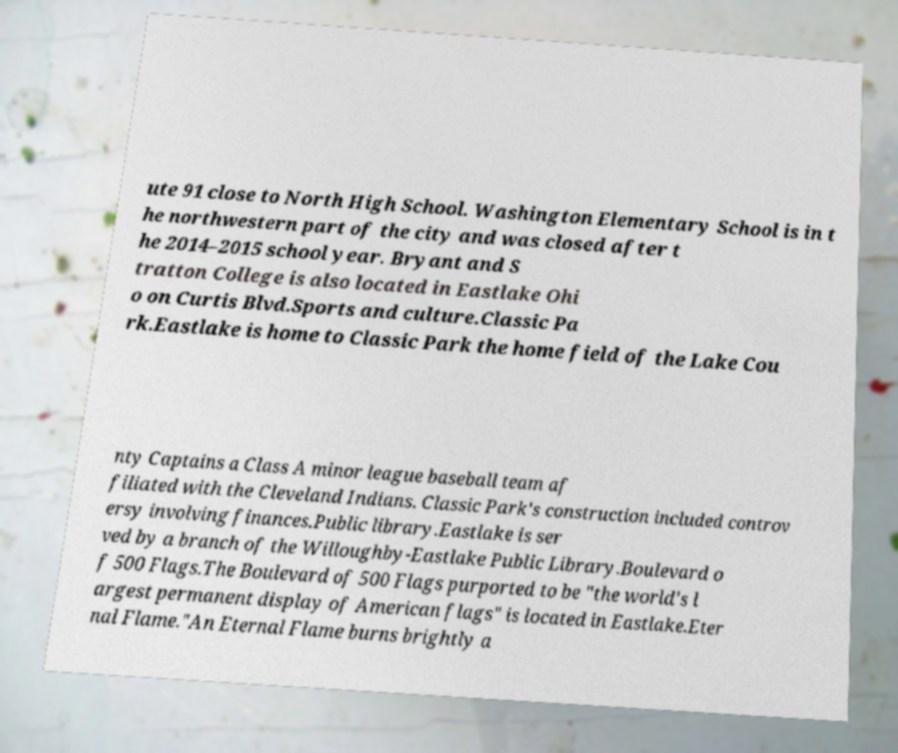I need the written content from this picture converted into text. Can you do that? ute 91 close to North High School. Washington Elementary School is in t he northwestern part of the city and was closed after t he 2014–2015 school year. Bryant and S tratton College is also located in Eastlake Ohi o on Curtis Blvd.Sports and culture.Classic Pa rk.Eastlake is home to Classic Park the home field of the Lake Cou nty Captains a Class A minor league baseball team af filiated with the Cleveland Indians. Classic Park's construction included controv ersy involving finances.Public library.Eastlake is ser ved by a branch of the Willoughby-Eastlake Public Library.Boulevard o f 500 Flags.The Boulevard of 500 Flags purported to be "the world's l argest permanent display of American flags" is located in Eastlake.Eter nal Flame."An Eternal Flame burns brightly a 